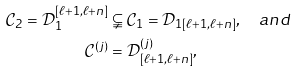Convert formula to latex. <formula><loc_0><loc_0><loc_500><loc_500>\mathcal { C } _ { 2 } = \mathcal { D } _ { 1 } ^ { [ \ell + 1 , \ell + n ] } & \subsetneqq \mathcal { C } _ { 1 } = \mathcal { D } _ { 1 [ \ell + 1 , \ell + n ] } , \quad a n d \\ \mathcal { C } ^ { ( j ) } & = \mathcal { D } ^ { ( j ) } _ { [ \ell + 1 , \ell + n ] } ,</formula> 